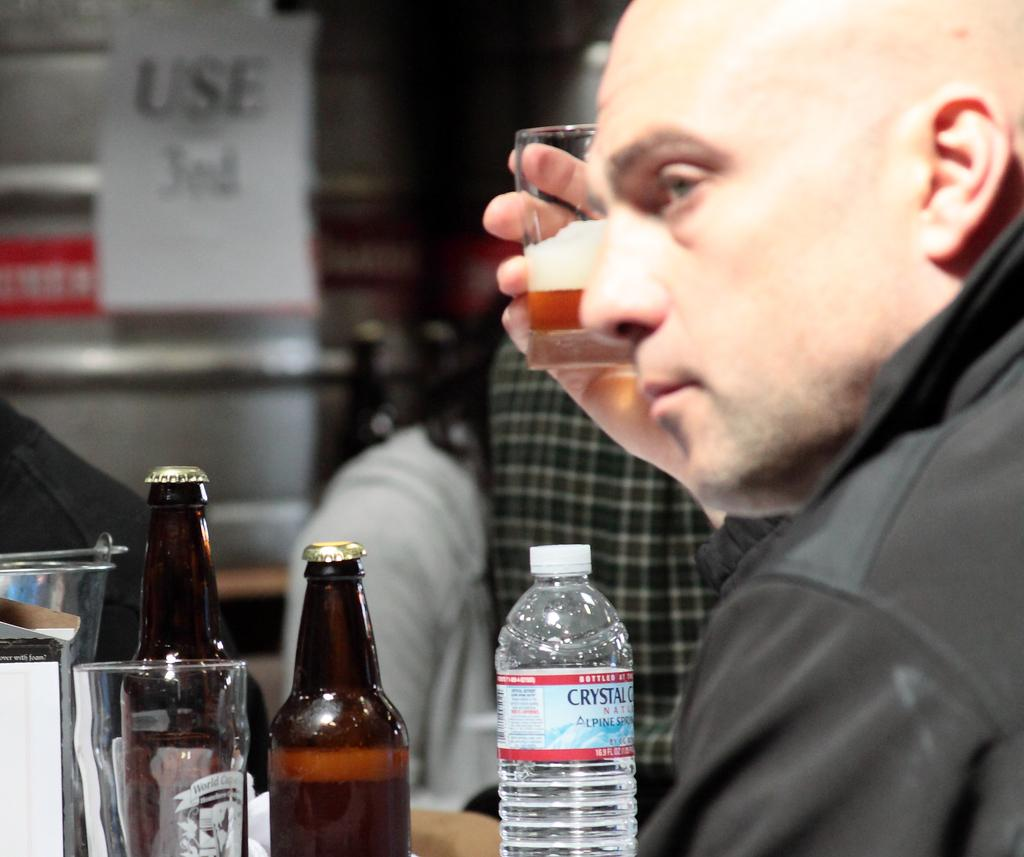<image>
Share a concise interpretation of the image provided. A man with beer bottles and a water bottle that says Crystal on it in front of him. 